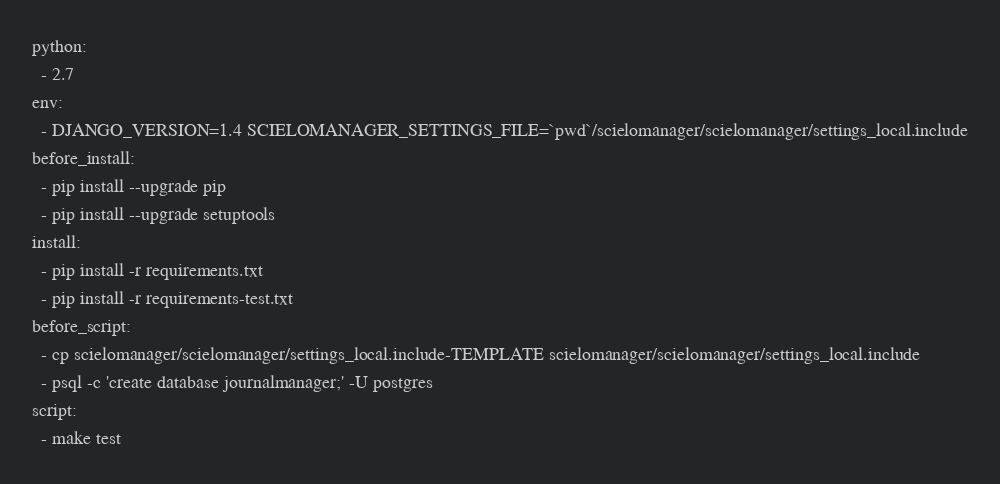Convert code to text. <code><loc_0><loc_0><loc_500><loc_500><_YAML_>python:
  - 2.7
env:
  - DJANGO_VERSION=1.4 SCIELOMANAGER_SETTINGS_FILE=`pwd`/scielomanager/scielomanager/settings_local.include
before_install:
  - pip install --upgrade pip
  - pip install --upgrade setuptools
install:
  - pip install -r requirements.txt
  - pip install -r requirements-test.txt
before_script:
  - cp scielomanager/scielomanager/settings_local.include-TEMPLATE scielomanager/scielomanager/settings_local.include
  - psql -c 'create database journalmanager;' -U postgres
script:
  - make test
</code> 